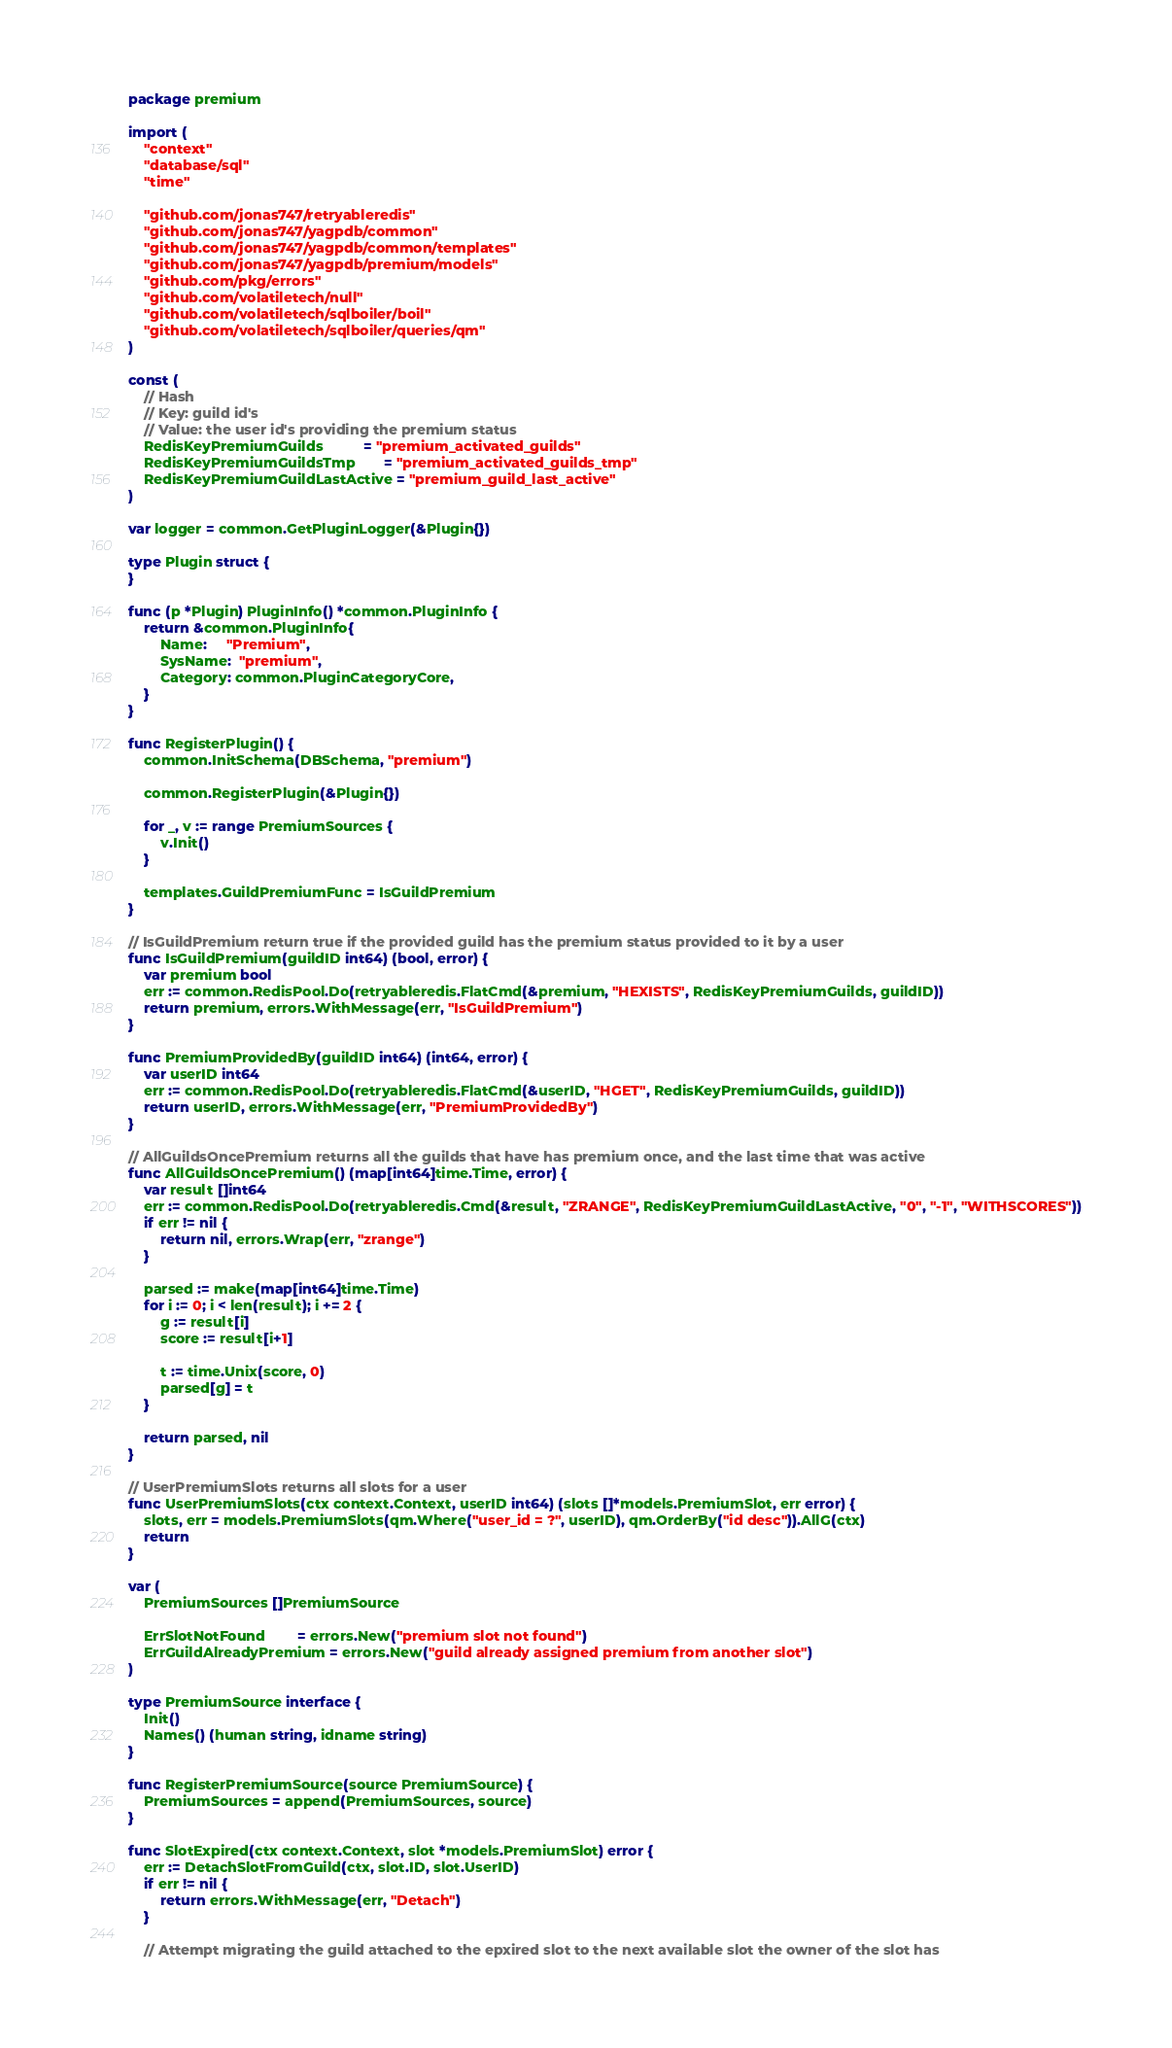Convert code to text. <code><loc_0><loc_0><loc_500><loc_500><_Go_>package premium

import (
	"context"
	"database/sql"
	"time"

	"github.com/jonas747/retryableredis"
	"github.com/jonas747/yagpdb/common"
	"github.com/jonas747/yagpdb/common/templates"
	"github.com/jonas747/yagpdb/premium/models"
	"github.com/pkg/errors"
	"github.com/volatiletech/null"
	"github.com/volatiletech/sqlboiler/boil"
	"github.com/volatiletech/sqlboiler/queries/qm"
)

const (
	// Hash
	// Key: guild id's
	// Value: the user id's providing the premium status
	RedisKeyPremiumGuilds          = "premium_activated_guilds"
	RedisKeyPremiumGuildsTmp       = "premium_activated_guilds_tmp"
	RedisKeyPremiumGuildLastActive = "premium_guild_last_active"
)

var logger = common.GetPluginLogger(&Plugin{})

type Plugin struct {
}

func (p *Plugin) PluginInfo() *common.PluginInfo {
	return &common.PluginInfo{
		Name:     "Premium",
		SysName:  "premium",
		Category: common.PluginCategoryCore,
	}
}

func RegisterPlugin() {
	common.InitSchema(DBSchema, "premium")

	common.RegisterPlugin(&Plugin{})

	for _, v := range PremiumSources {
		v.Init()
	}

	templates.GuildPremiumFunc = IsGuildPremium
}

// IsGuildPremium return true if the provided guild has the premium status provided to it by a user
func IsGuildPremium(guildID int64) (bool, error) {
	var premium bool
	err := common.RedisPool.Do(retryableredis.FlatCmd(&premium, "HEXISTS", RedisKeyPremiumGuilds, guildID))
	return premium, errors.WithMessage(err, "IsGuildPremium")
}

func PremiumProvidedBy(guildID int64) (int64, error) {
	var userID int64
	err := common.RedisPool.Do(retryableredis.FlatCmd(&userID, "HGET", RedisKeyPremiumGuilds, guildID))
	return userID, errors.WithMessage(err, "PremiumProvidedBy")
}

// AllGuildsOncePremium returns all the guilds that have has premium once, and the last time that was active
func AllGuildsOncePremium() (map[int64]time.Time, error) {
	var result []int64
	err := common.RedisPool.Do(retryableredis.Cmd(&result, "ZRANGE", RedisKeyPremiumGuildLastActive, "0", "-1", "WITHSCORES"))
	if err != nil {
		return nil, errors.Wrap(err, "zrange")
	}

	parsed := make(map[int64]time.Time)
	for i := 0; i < len(result); i += 2 {
		g := result[i]
		score := result[i+1]

		t := time.Unix(score, 0)
		parsed[g] = t
	}

	return parsed, nil
}

// UserPremiumSlots returns all slots for a user
func UserPremiumSlots(ctx context.Context, userID int64) (slots []*models.PremiumSlot, err error) {
	slots, err = models.PremiumSlots(qm.Where("user_id = ?", userID), qm.OrderBy("id desc")).AllG(ctx)
	return
}

var (
	PremiumSources []PremiumSource

	ErrSlotNotFound        = errors.New("premium slot not found")
	ErrGuildAlreadyPremium = errors.New("guild already assigned premium from another slot")
)

type PremiumSource interface {
	Init()
	Names() (human string, idname string)
}

func RegisterPremiumSource(source PremiumSource) {
	PremiumSources = append(PremiumSources, source)
}

func SlotExpired(ctx context.Context, slot *models.PremiumSlot) error {
	err := DetachSlotFromGuild(ctx, slot.ID, slot.UserID)
	if err != nil {
		return errors.WithMessage(err, "Detach")
	}

	// Attempt migrating the guild attached to the epxired slot to the next available slot the owner of the slot has</code> 